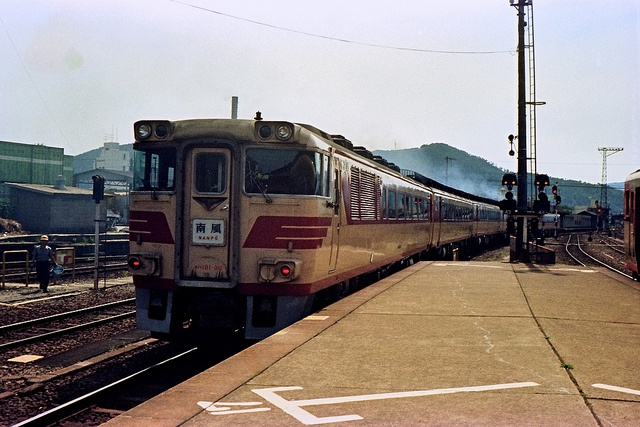Describe the objects in this image and their specific colors. I can see train in lavender, black, gray, and maroon tones, train in lavender, black, maroon, gray, and brown tones, people in lavender, black, gray, and white tones, traffic light in lavender, black, gray, and darkgray tones, and traffic light in lavender, black, gray, navy, and maroon tones in this image. 